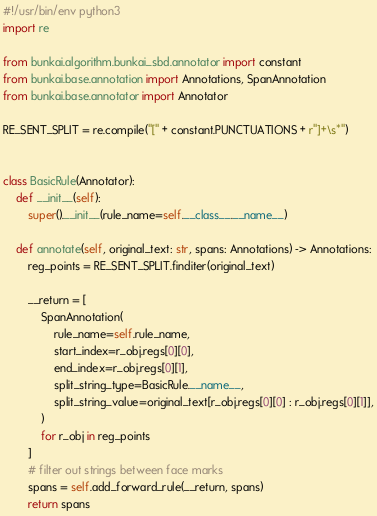Convert code to text. <code><loc_0><loc_0><loc_500><loc_500><_Python_>#!/usr/bin/env python3
import re

from bunkai.algorithm.bunkai_sbd.annotator import constant
from bunkai.base.annotation import Annotations, SpanAnnotation
from bunkai.base.annotator import Annotator

RE_SENT_SPLIT = re.compile("[" + constant.PUNCTUATIONS + r"]+\s*")


class BasicRule(Annotator):
    def __init__(self):
        super().__init__(rule_name=self.__class__.__name__)

    def annotate(self, original_text: str, spans: Annotations) -> Annotations:
        reg_points = RE_SENT_SPLIT.finditer(original_text)

        __return = [
            SpanAnnotation(
                rule_name=self.rule_name,
                start_index=r_obj.regs[0][0],
                end_index=r_obj.regs[0][1],
                split_string_type=BasicRule.__name__,
                split_string_value=original_text[r_obj.regs[0][0] : r_obj.regs[0][1]],
            )
            for r_obj in reg_points
        ]
        # filter out strings between face marks
        spans = self.add_forward_rule(__return, spans)
        return spans
</code> 